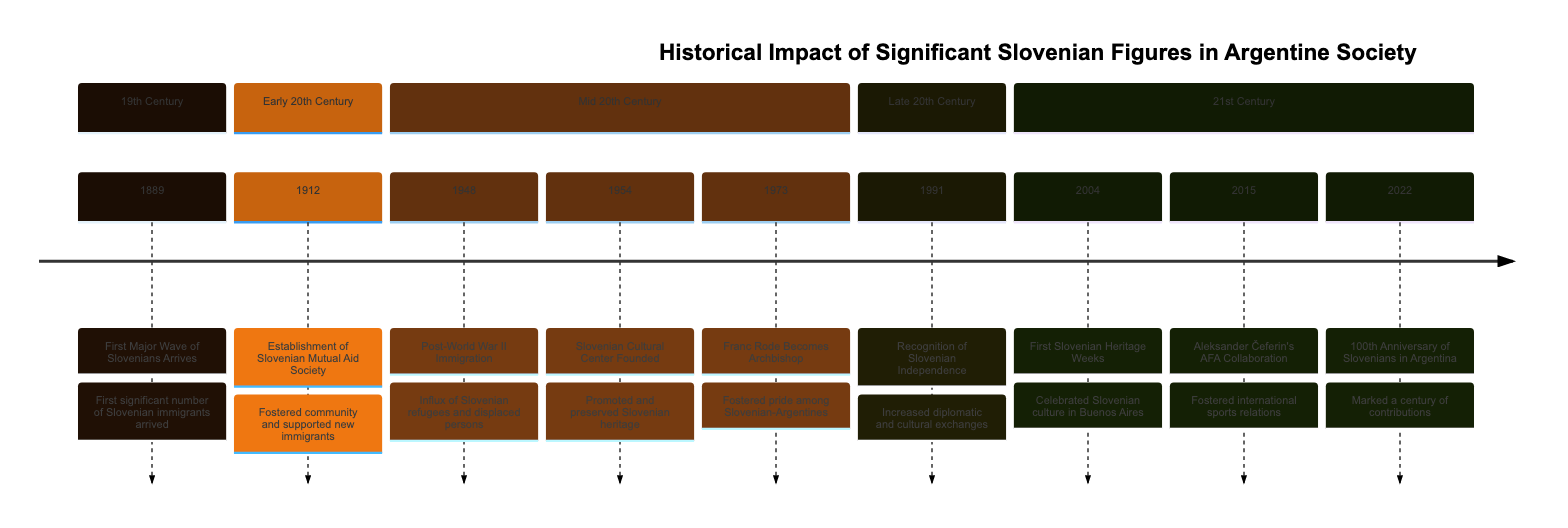What year did the first major wave of Slovenians arrive in Argentina? The diagram shows the event "First Major Wave of Slovenians Arrives" occurring in the year "1889," specifically mentioned as the first significant number of Slovenian immigrants arriving.
Answer: 1889 What event occurred in 1954? Referring to the timeline, the year "1954" is associated with the event "Slovenian Cultural Center Founded," which is described as promoting and preserving Slovenian heritage.
Answer: Slovenian Cultural Center Founded How many significant events are listed in the timeline? By counting the number of timeline elements, we see that there are a total of 8 events mentioned across different years, confirming the number of significant historical moments included.
Answer: 8 Which event marked the recognition of Slovenian independence? The timeline indicates that "Recognition of Slovenian Independence" is highlighted in the year "1991," connecting it with the increased diplomatic and cultural exchanges.
Answer: Recognition of Slovenian Independence What was established in 1912? According to the timeline, the establishment of the "Slovenian Mutual Aid Society" occurred in "1912," aimed at fostering community and support for new immigrants, which is explicitly stated.
Answer: Slovenian Mutual Aid Society Which year signifies the 100th anniversary of Slovenians in Argentina? The timeline shows the year "2022" as the year marking the "100th Anniversary of Slovenians in Argentina," indicating a celebration of a century of contributions.
Answer: 2022 What was the significance of Franc Rode's appointment in 1973? Referring to the timeline, Franc Rode's appointment as the Archbishop in "1973" is noted to have fostered pride among the Slovenian-Argentine community, showing its significance.
Answer: Fostered pride among Slovenian-Argentines What cultural event began in 2004? The timeline notes that "First Slovenian Heritage Weeks" began in "2004," stating that it celebrated and raised awareness of Slovenian culture and history in Buenos Aires.
Answer: First Slovenian Heritage Weeks How did Aleksander Čeferin contribute to Argentine society in 2015? According to the timeline, Aleksander Čeferin collaborated with the Argentine Football Association in "2015," aimed at fostering better international sports relations, explaining his contribution.
Answer: Collaborated with AFA 